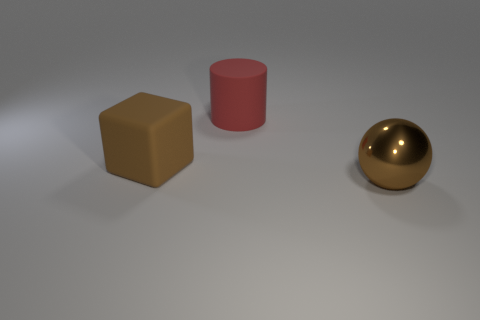Add 2 brown rubber things. How many objects exist? 5 Subtract all spheres. How many objects are left? 2 Add 1 large red matte cylinders. How many large red matte cylinders are left? 2 Add 3 green metallic cylinders. How many green metallic cylinders exist? 3 Subtract 0 green cylinders. How many objects are left? 3 Subtract all red rubber cylinders. Subtract all big brown shiny objects. How many objects are left? 1 